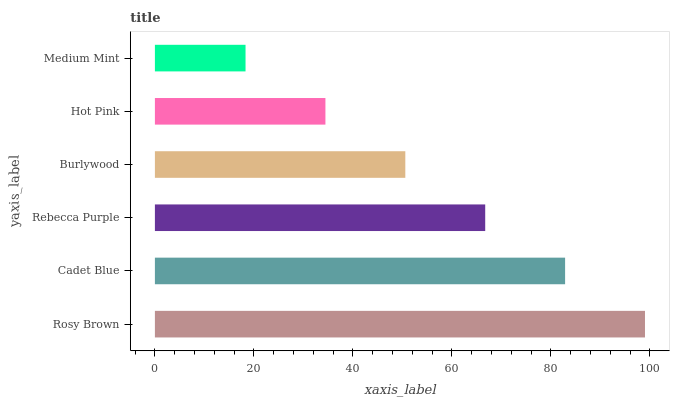Is Medium Mint the minimum?
Answer yes or no. Yes. Is Rosy Brown the maximum?
Answer yes or no. Yes. Is Cadet Blue the minimum?
Answer yes or no. No. Is Cadet Blue the maximum?
Answer yes or no. No. Is Rosy Brown greater than Cadet Blue?
Answer yes or no. Yes. Is Cadet Blue less than Rosy Brown?
Answer yes or no. Yes. Is Cadet Blue greater than Rosy Brown?
Answer yes or no. No. Is Rosy Brown less than Cadet Blue?
Answer yes or no. No. Is Rebecca Purple the high median?
Answer yes or no. Yes. Is Burlywood the low median?
Answer yes or no. Yes. Is Burlywood the high median?
Answer yes or no. No. Is Hot Pink the low median?
Answer yes or no. No. 